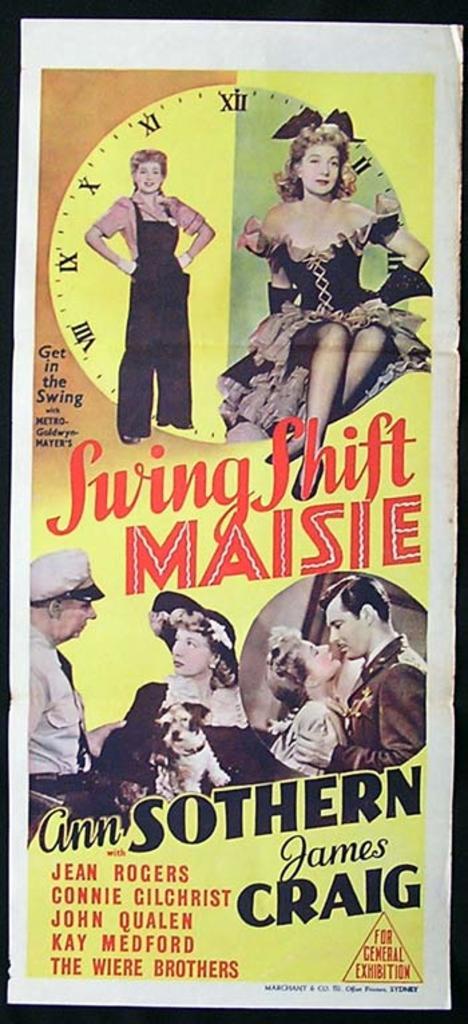What kind of pet does the woman have?
Your answer should be very brief. Dog. What is the title of this movie?
Your answer should be compact. Swing shift maisie. 